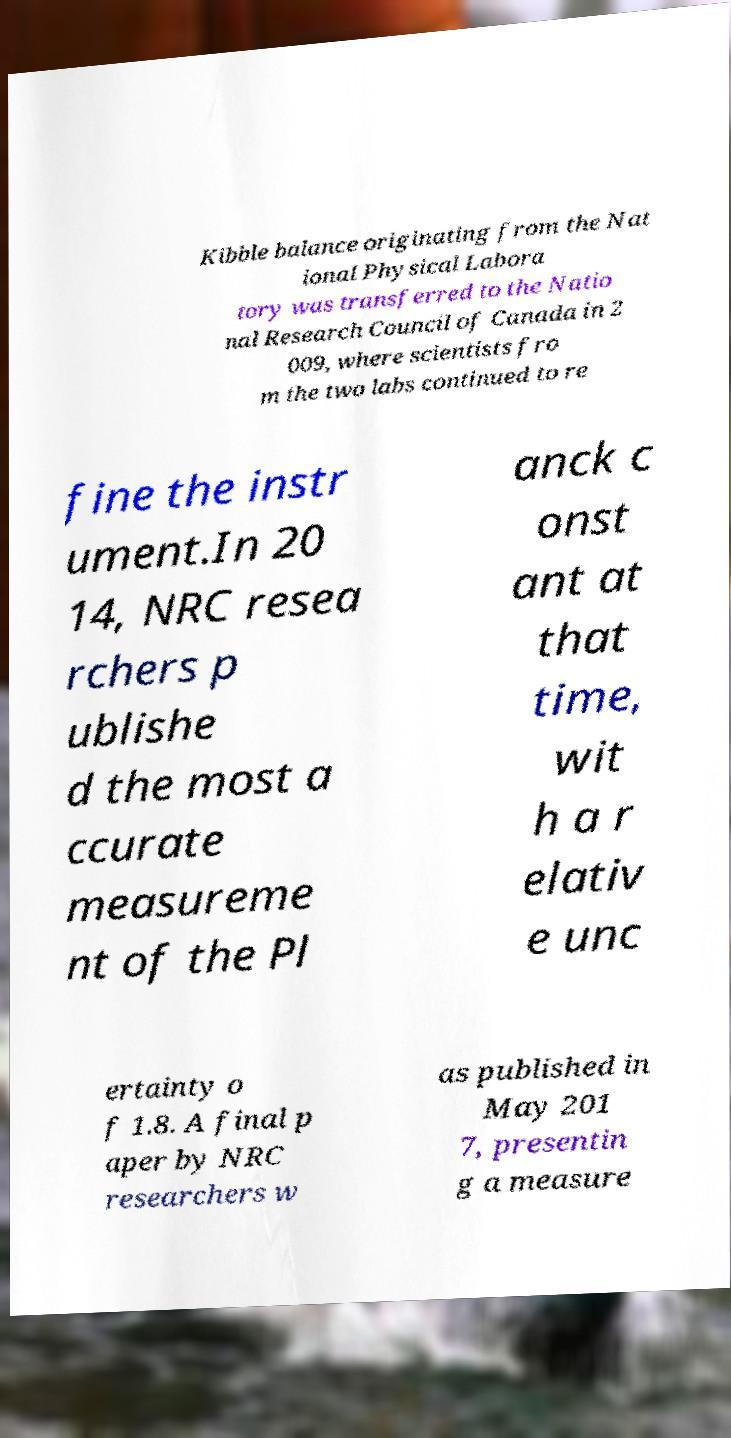What messages or text are displayed in this image? I need them in a readable, typed format. Kibble balance originating from the Nat ional Physical Labora tory was transferred to the Natio nal Research Council of Canada in 2 009, where scientists fro m the two labs continued to re fine the instr ument.In 20 14, NRC resea rchers p ublishe d the most a ccurate measureme nt of the Pl anck c onst ant at that time, wit h a r elativ e unc ertainty o f 1.8. A final p aper by NRC researchers w as published in May 201 7, presentin g a measure 